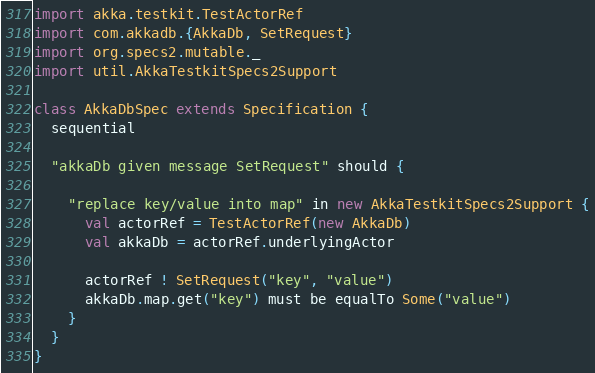Convert code to text. <code><loc_0><loc_0><loc_500><loc_500><_Scala_>import akka.testkit.TestActorRef
import com.akkadb.{AkkaDb, SetRequest}
import org.specs2.mutable._
import util.AkkaTestkitSpecs2Support

class AkkaDbSpec extends Specification {
  sequential

  "akkaDb given message SetRequest" should {

    "replace key/value into map" in new AkkaTestkitSpecs2Support {
      val actorRef = TestActorRef(new AkkaDb)
      val akkaDb = actorRef.underlyingActor

      actorRef ! SetRequest("key", "value")
      akkaDb.map.get("key") must be equalTo Some("value")
    }
  }
}
</code> 